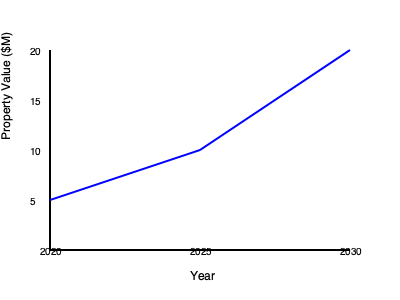The line graph shows the projected value of a property investment over time. What is the percentage increase in property value from 2020 to 2030? To calculate the percentage increase in property value from 2020 to 2030, we need to follow these steps:

1. Identify the property values:
   - In 2020: $5 million
   - In 2030: $20 million

2. Calculate the difference in value:
   $20 million - $5 million = $15 million

3. Use the percentage increase formula:
   Percentage increase = $\frac{\text{Increase}}{\text{Original Value}} \times 100\%$

4. Plug in the values:
   Percentage increase = $\frac{15}{5} \times 100\%$

5. Simplify:
   Percentage increase = $3 \times 100\% = 300\%$

Therefore, the percentage increase in property value from 2020 to 2030 is 300%.
Answer: 300% 